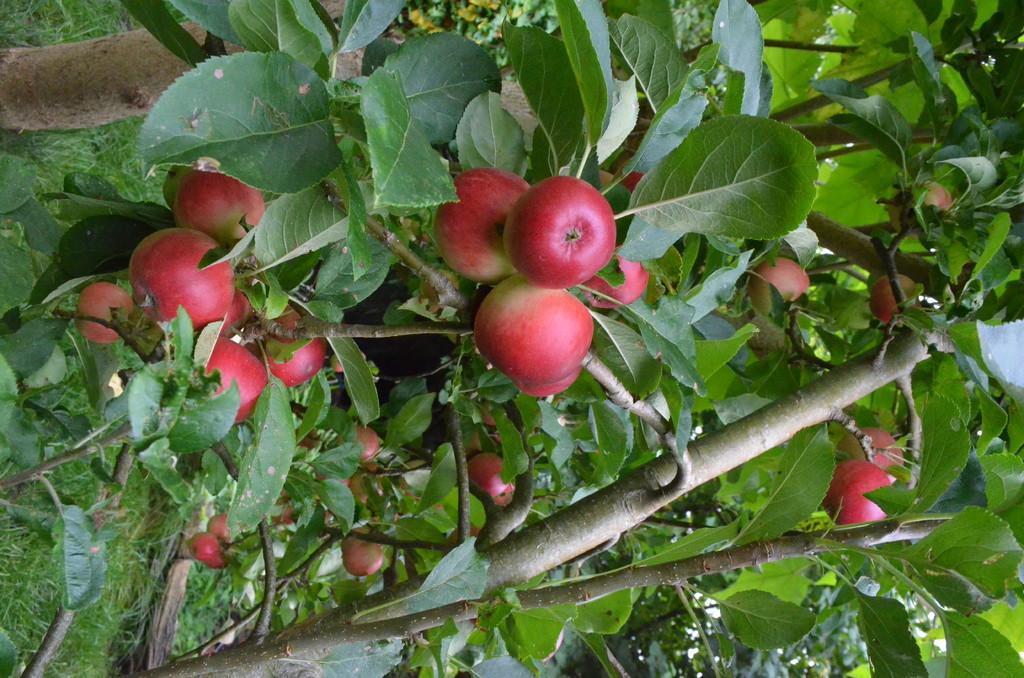What type of objects are present in the image? There is a group of fruits in the image. What can be seen on the branches of the trees in the image? There are leaves on the branches of the trees in the image. What type of vegetation is visible in the background of the image? There is grass visible in the background of the image. How many birthday tickets are visible in the image? There are no birthday tickets present in the image. 